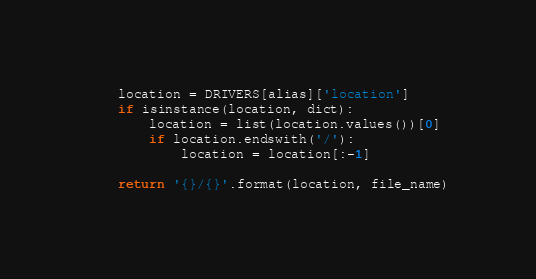<code> <loc_0><loc_0><loc_500><loc_500><_Python_>
    location = DRIVERS[alias]['location']
    if isinstance(location, dict):
        location = list(location.values())[0]
        if location.endswith('/'):
            location = location[:-1]

    return '{}/{}'.format(location, file_name)
</code> 